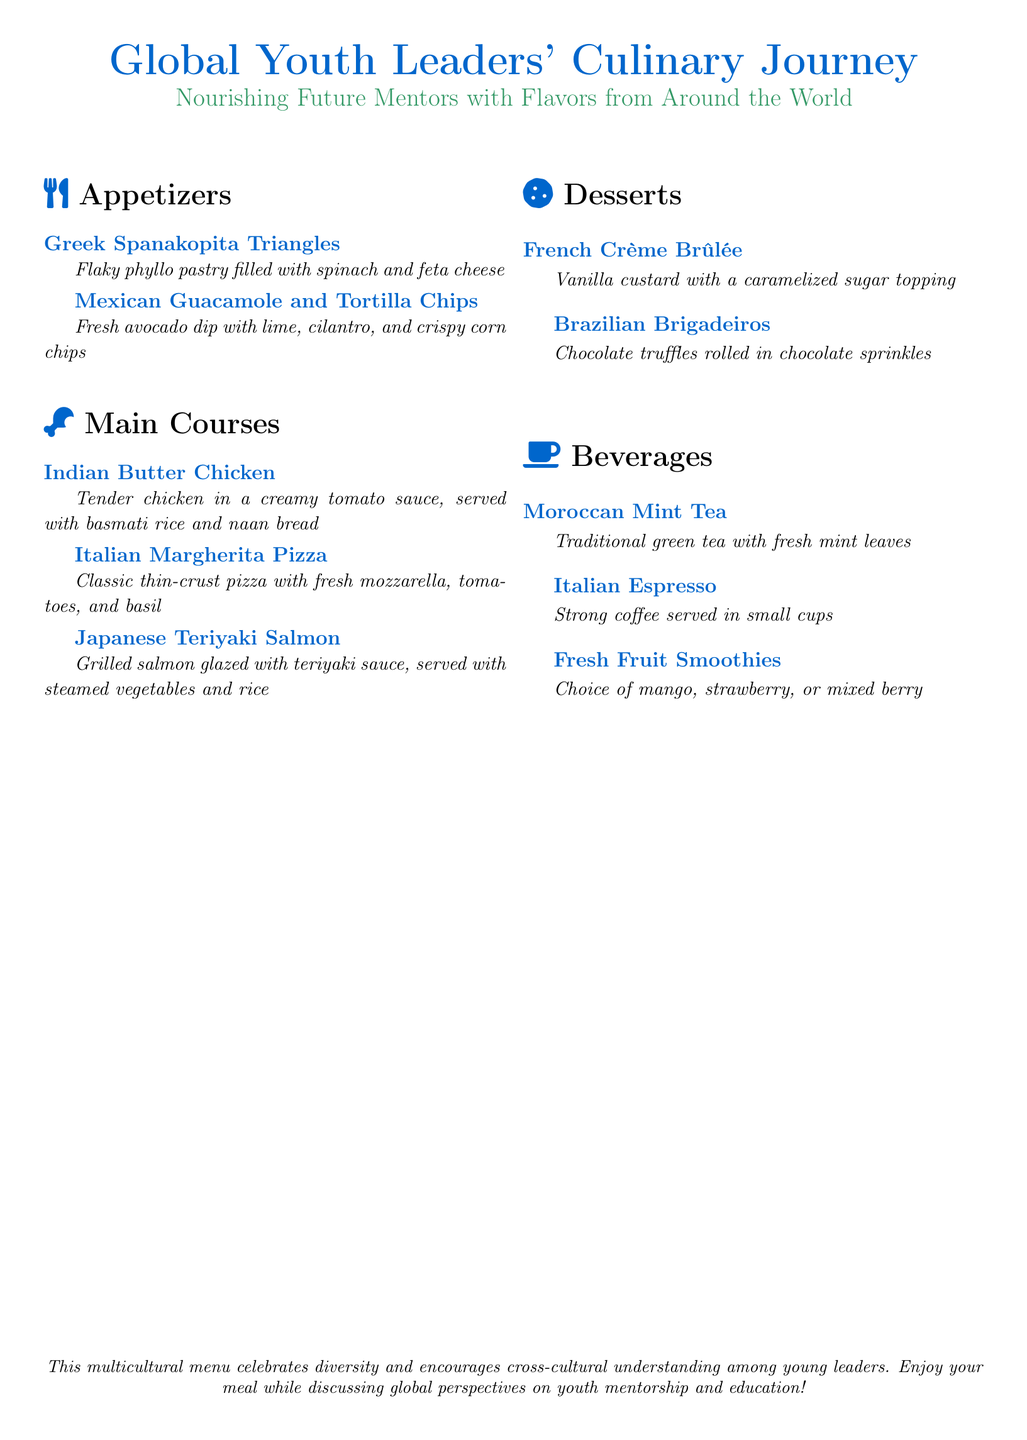What is the title of the menu? The title is presented at the top of the document, highlighting the culinary theme of the event.
Answer: Global Youth Leaders' Culinary Journey What is the first appetizer listed? The first appetizer is mentioned in the appetizers section and describes a Greek dish.
Answer: Greek Spanakopita Triangles How many main courses are included in the menu? The main courses section lists the number of dishes provided, which are commonly offered in such menus.
Answer: 3 What type of dessert is a Brazilian dish? This question pertains to identifying a specific dessert originating from Brazil as seen in the desserts section.
Answer: Brigadeiros What beverage includes fresh mint leaves? The beverage section describes a traditional drink that includes mint, highlighting its cultural origin.
Answer: Moroccan Mint Tea What cuisine is featured in the last item listed? This question examines the last item mentioned in the menu that corresponds to a specific cultural beverage.
Answer: Fresh Fruit Smoothies Which main course is classified as Italian? This question focuses on identifying the dish that represents Italian cuisine as per the main courses section.
Answer: Margherita Pizza What topping is on the French dessert? The dessert section describes a French dish that is characterized by a particular topping.
Answer: Caramelized sugar topping 